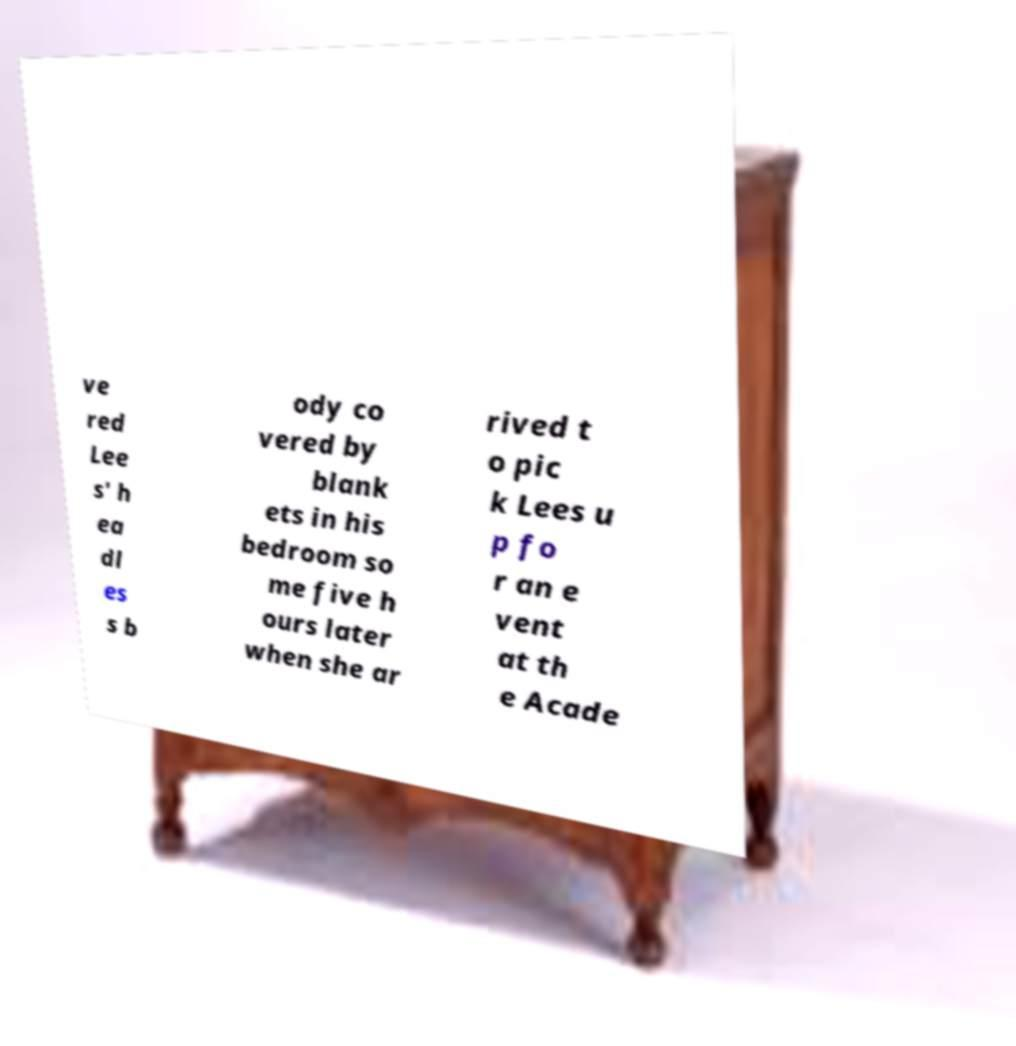What messages or text are displayed in this image? I need them in a readable, typed format. ve red Lee s' h ea dl es s b ody co vered by blank ets in his bedroom so me five h ours later when she ar rived t o pic k Lees u p fo r an e vent at th e Acade 